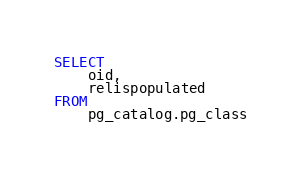Convert code to text. <code><loc_0><loc_0><loc_500><loc_500><_SQL_>SELECT 
    oid,
    relispopulated
FROM 
    pg_catalog.pg_class</code> 